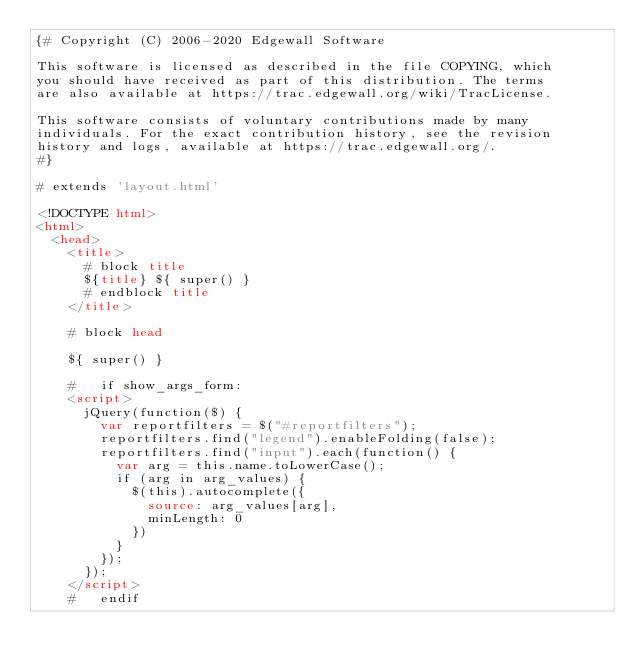Convert code to text. <code><loc_0><loc_0><loc_500><loc_500><_HTML_>{# Copyright (C) 2006-2020 Edgewall Software

This software is licensed as described in the file COPYING, which
you should have received as part of this distribution. The terms
are also available at https://trac.edgewall.org/wiki/TracLicense.

This software consists of voluntary contributions made by many
individuals. For the exact contribution history, see the revision
history and logs, available at https://trac.edgewall.org/.
#}

# extends 'layout.html'

<!DOCTYPE html>
<html>
  <head>
    <title>
      # block title
      ${title} ${ super() }
      # endblock title
    </title>

    # block head

    ${ super() }

    #   if show_args_form:
    <script>
      jQuery(function($) {
        var reportfilters = $("#reportfilters");
        reportfilters.find("legend").enableFolding(false);
        reportfilters.find("input").each(function() {
          var arg = this.name.toLowerCase();
          if (arg in arg_values) {
            $(this).autocomplete({
              source: arg_values[arg],
              minLength: 0
            })
          }
        });
      });
    </script>
    #   endif
</code> 